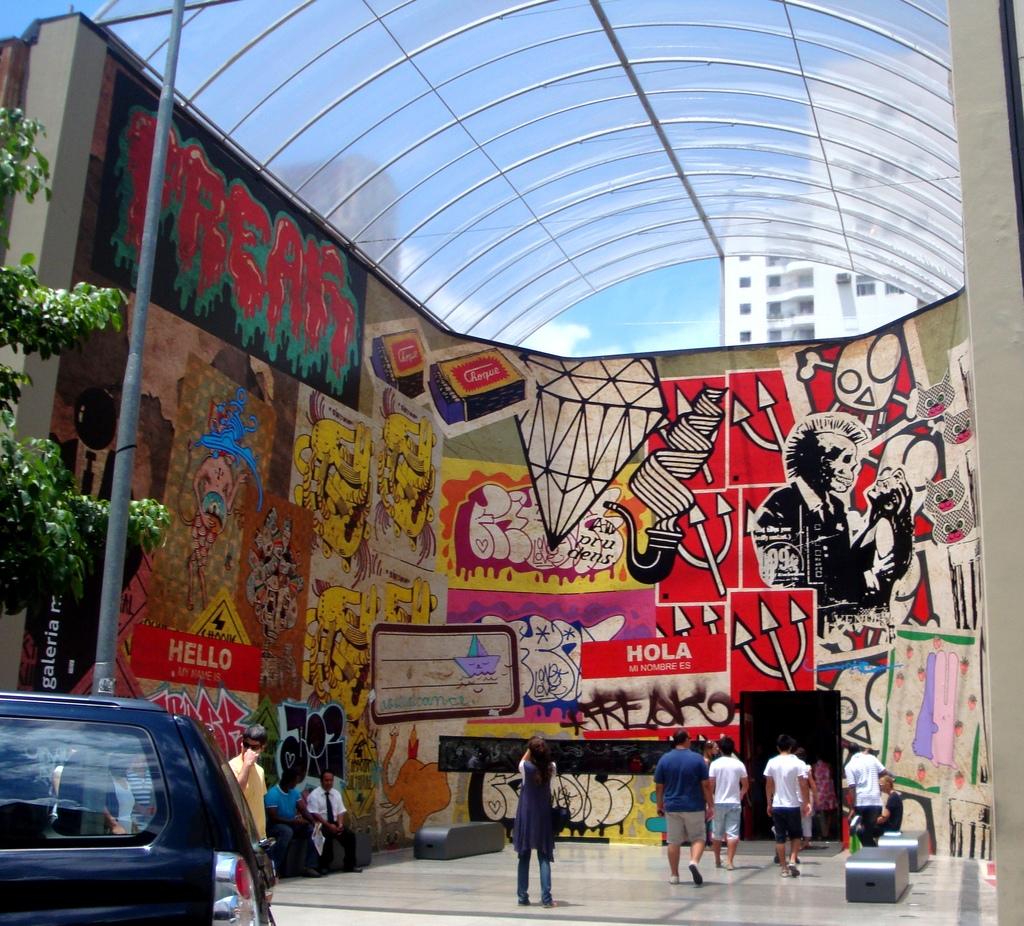What greeting is written on the left wall with a red background?
Make the answer very short. Hello. Which languages are displayed in this street art?
Make the answer very short. English, spanish. 